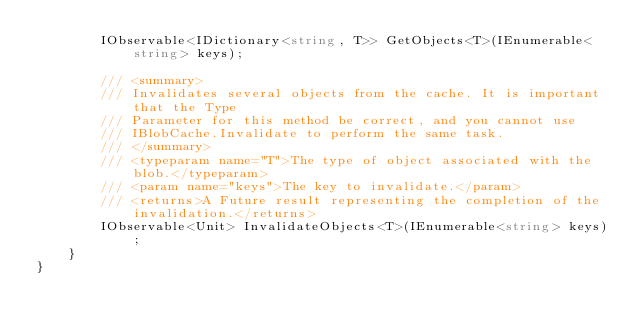Convert code to text. <code><loc_0><loc_0><loc_500><loc_500><_C#_>        IObservable<IDictionary<string, T>> GetObjects<T>(IEnumerable<string> keys);

        /// <summary>
        /// Invalidates several objects from the cache. It is important that the Type
        /// Parameter for this method be correct, and you cannot use
        /// IBlobCache.Invalidate to perform the same task.
        /// </summary>
        /// <typeparam name="T">The type of object associated with the blob.</typeparam>
        /// <param name="keys">The key to invalidate.</param>
        /// <returns>A Future result representing the completion of the invalidation.</returns>
        IObservable<Unit> InvalidateObjects<T>(IEnumerable<string> keys);
    }
}
</code> 